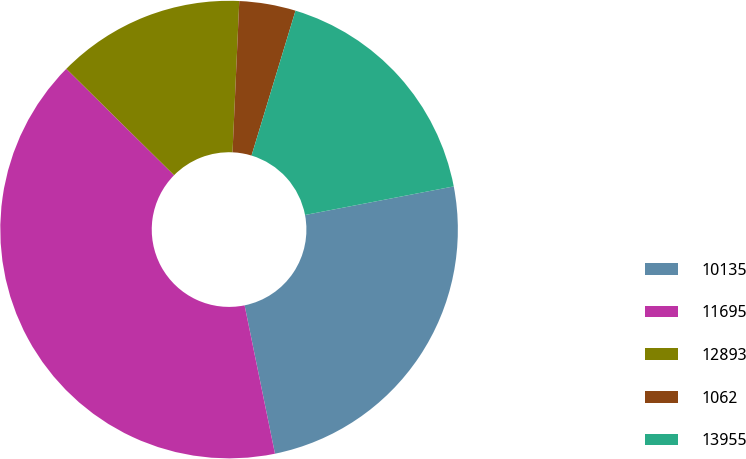Convert chart to OTSL. <chart><loc_0><loc_0><loc_500><loc_500><pie_chart><fcel>10135<fcel>11695<fcel>12893<fcel>1062<fcel>13955<nl><fcel>24.81%<fcel>40.62%<fcel>13.31%<fcel>3.98%<fcel>17.29%<nl></chart> 